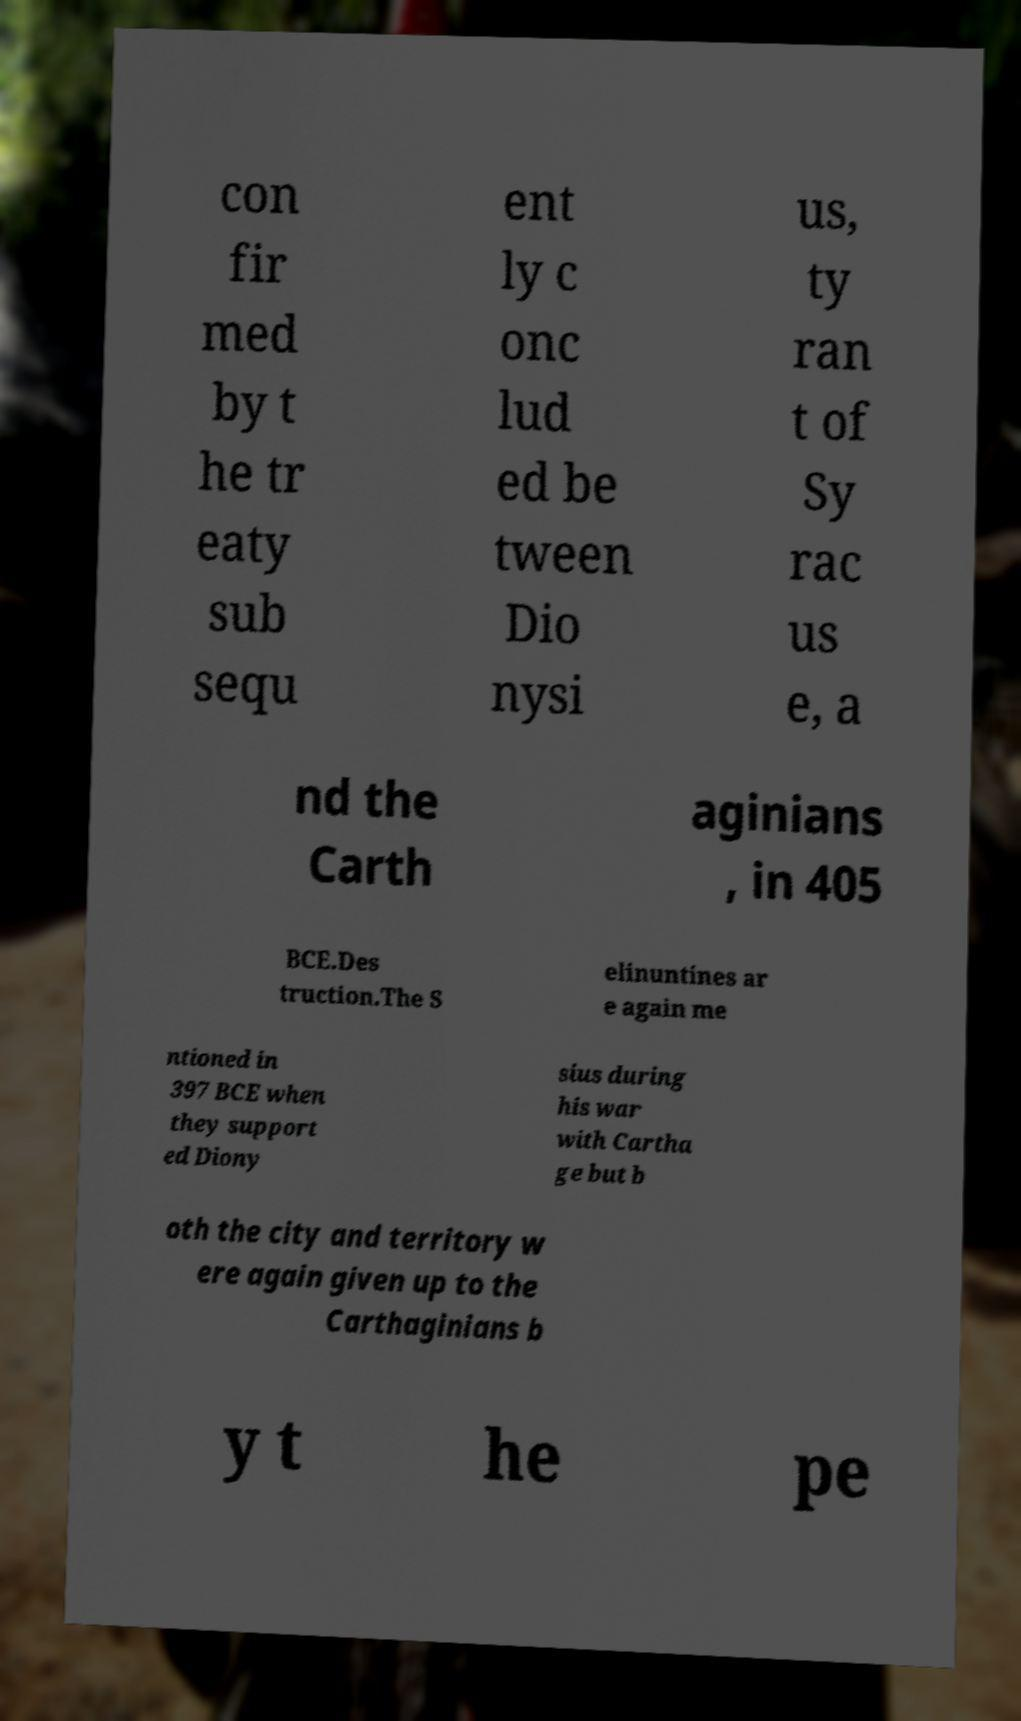What messages or text are displayed in this image? I need them in a readable, typed format. con fir med by t he tr eaty sub sequ ent ly c onc lud ed be tween Dio nysi us, ty ran t of Sy rac us e, a nd the Carth aginians , in 405 BCE.Des truction.The S elinuntines ar e again me ntioned in 397 BCE when they support ed Diony sius during his war with Cartha ge but b oth the city and territory w ere again given up to the Carthaginians b y t he pe 